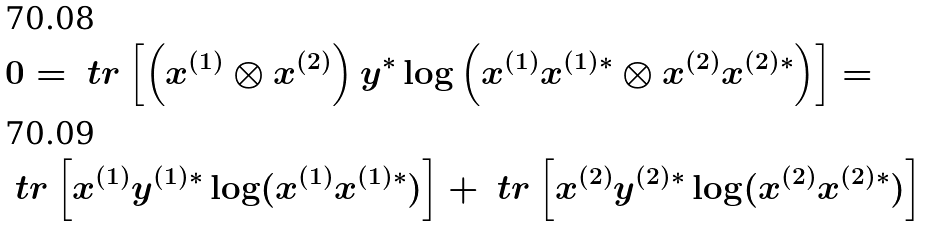<formula> <loc_0><loc_0><loc_500><loc_500>& 0 = \ t r \left [ \left ( x ^ { ( 1 ) } \otimes x ^ { ( 2 ) } \right ) y ^ { * } \log \left ( x ^ { ( 1 ) } x ^ { ( 1 ) * } \otimes x ^ { ( 2 ) } x ^ { ( 2 ) * } \right ) \right ] = \\ & \ t r \left [ x ^ { ( 1 ) } y ^ { ( 1 ) * } \log ( x ^ { ( 1 ) } x ^ { ( 1 ) * } ) \right ] + \ t r \left [ x ^ { ( 2 ) } y ^ { ( 2 ) * } \log ( x ^ { ( 2 ) } x ^ { ( 2 ) * } ) \right ]</formula> 